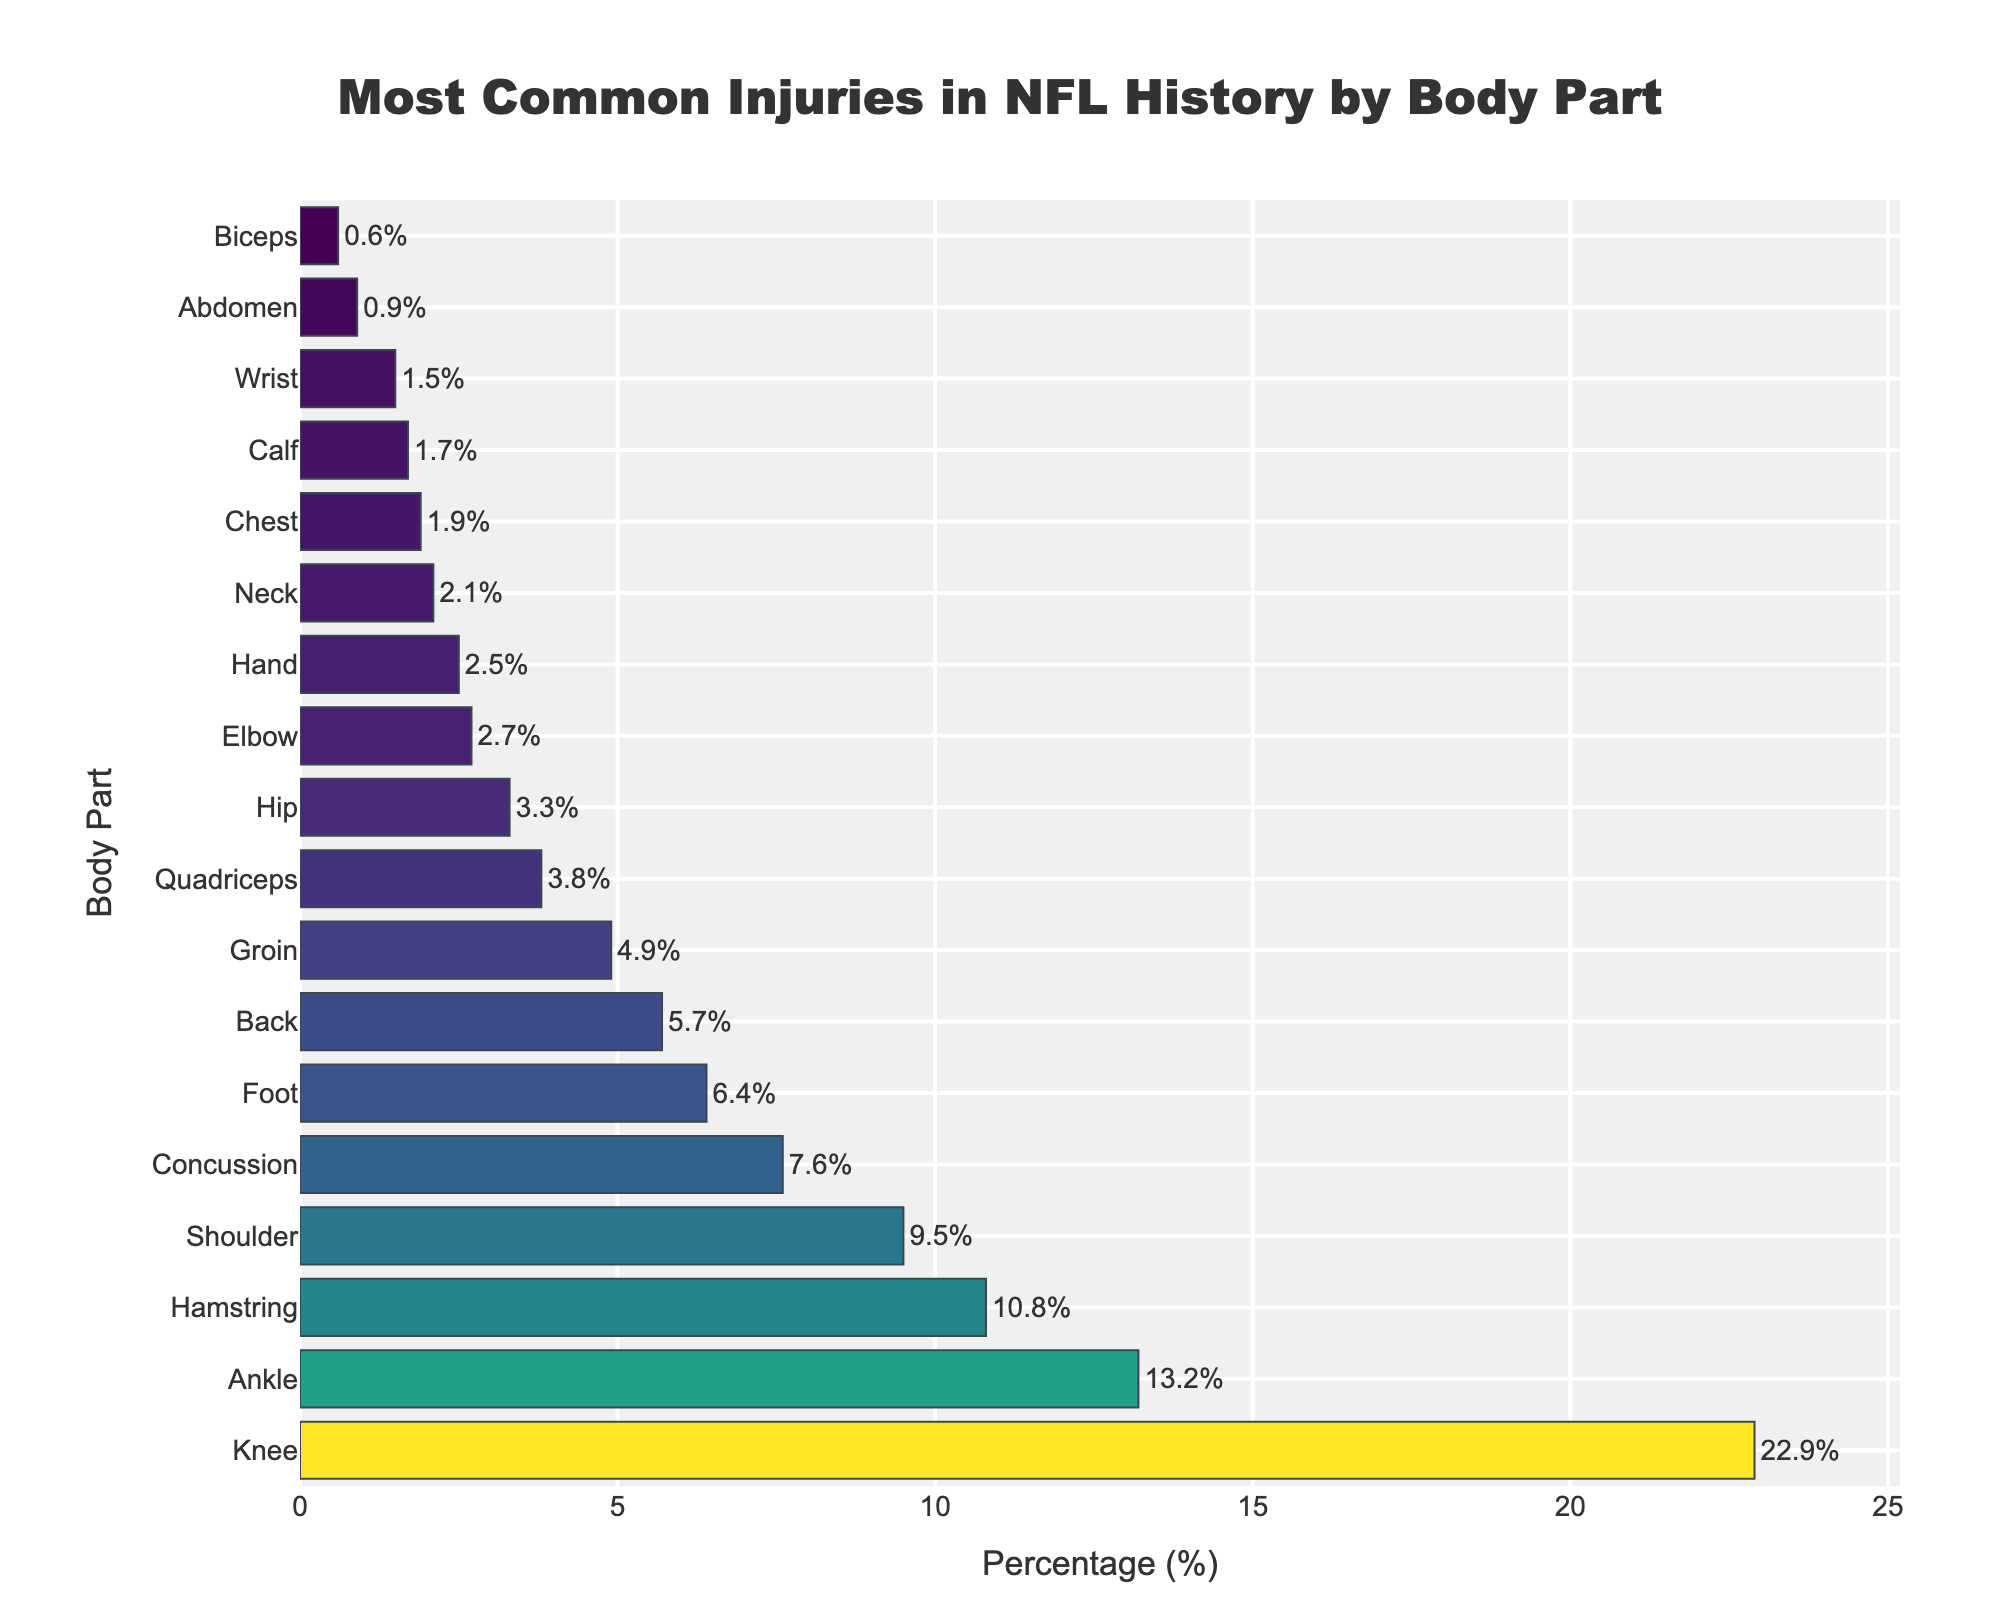Which body part has the highest percentage of injuries? The bar representing the knee is the longest in the figure, indicating that the knee has the highest percentage of injuries.
Answer: Knee How much higher is the percentage of knee injuries compared to ankle injuries? The knee is represented by a bar at 22.9% and the ankle by a bar at 13.2%. Subtracting the ankle percentage from the knee percentage gives 22.9% - 13.2% = 9.7%.
Answer: 9.7% Which two body parts have the closest percentages of injuries, and what are those percentages? The closest percentages are for 'Neck' and 'Chest', each slightly different at 2.1% and 1.9%.
Answer: Neck (2.1%) and Chest (1.9%) What is the combined percentage of injuries for the top three most affected body parts? Sum of the percentages for Knee (22.9%), Ankle (13.2%), and Hamstring (10.8%) is 22.9 + 13.2 + 10.8 = 46.9%.
Answer: 46.9% What is the average percentage of injuries for the body parts listed in the figure? Summing up all the percentages (22.9 + 13.2 + 10.8 + 9.5 + 7.6 + 6.4 + 5.7 + 4.9 + 3.8 + 3.3 + 2.7 + 2.5 + 2.1 + 1.9 + 1.7 + 1.5 + 0.9 + 0.6) and dividing by the number of body parts (18) gives (100.4 / 18) ≈ 5.58%.
Answer: 5.58% Which body part has nearly the same percentage of injuries as the combined percentage of injuries for elbow and hand? The combined percentage of injuries for elbow (2.7%) and hand (2.5%) is 2.7 + 2.5 = 5.2%. The back has a percentage of 5.7%, which is very close to 5.2%.
Answer: Back Are wrist injuries more or less common than abdominal injuries, and by how much? Wrist injuries are represented by a 1.5% bar, while abdominal injuries show a 0.9% bar. Subtracting the abdominal percentage from wrist gives 1.5% - 0.9% = 0.6%.
Answer: Wrist injuries are more common by 0.6% Which injury type is represented by a bar of approximately 7.6%? The concussion injury bar is approximately at 7.6%.
Answer: Concussion 